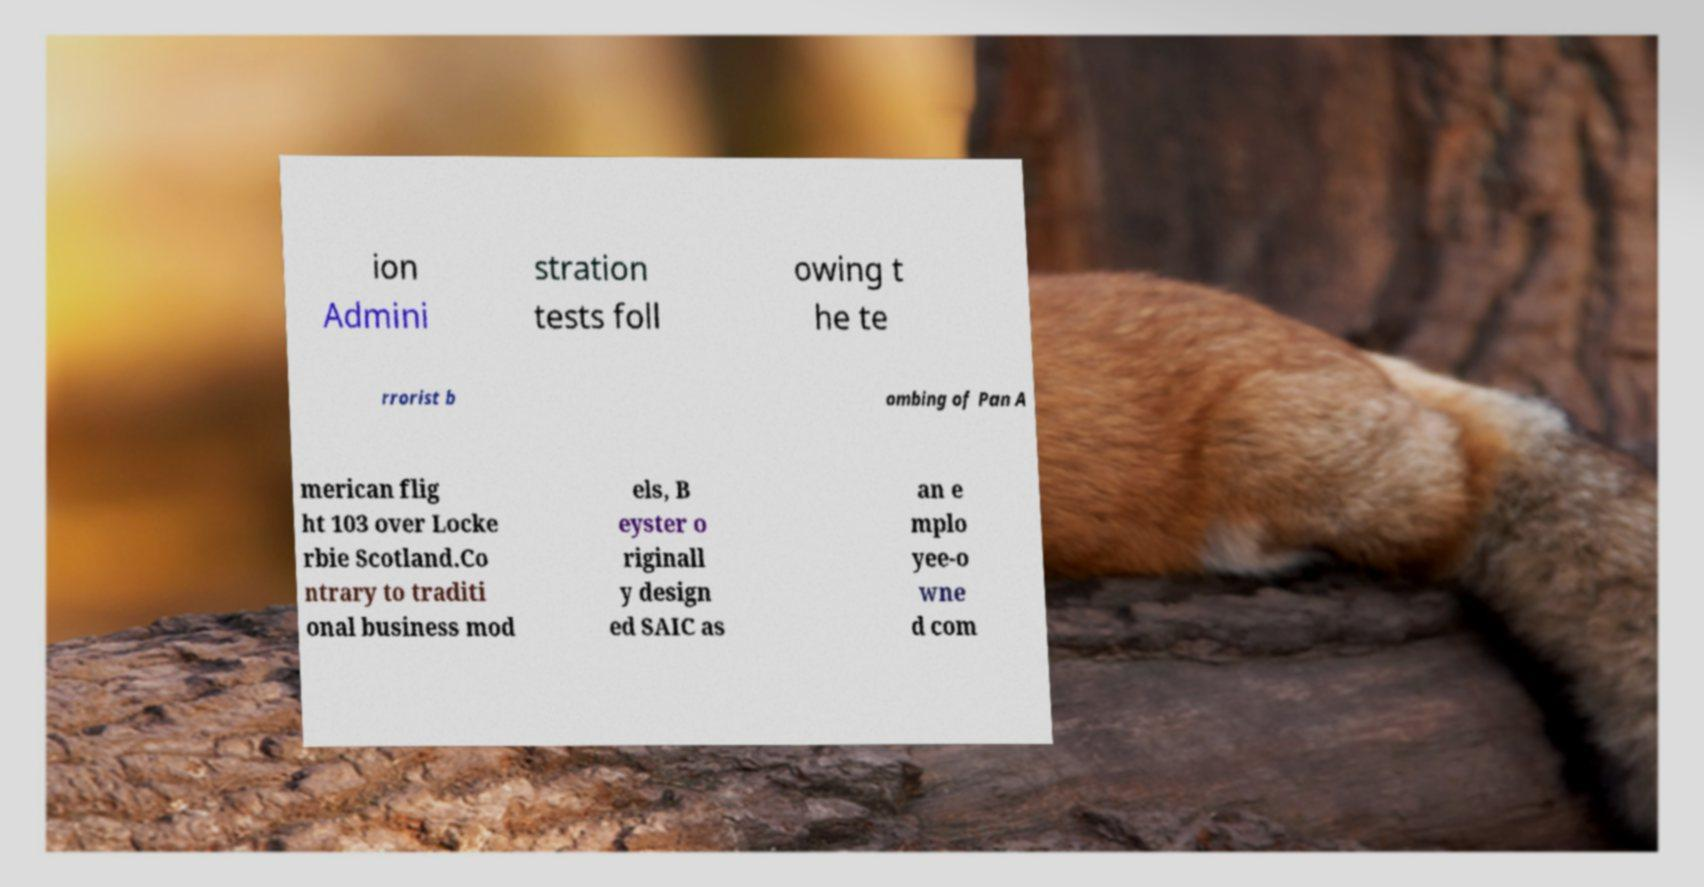For documentation purposes, I need the text within this image transcribed. Could you provide that? ion Admini stration tests foll owing t he te rrorist b ombing of Pan A merican flig ht 103 over Locke rbie Scotland.Co ntrary to traditi onal business mod els, B eyster o riginall y design ed SAIC as an e mplo yee-o wne d com 